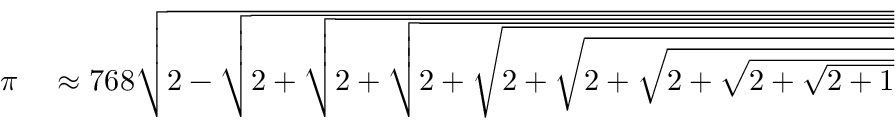<formula> <loc_0><loc_0><loc_500><loc_500>\begin{array} { r l } { \pi } & \approx 7 6 8 { \sqrt { 2 - { \sqrt { 2 + { \sqrt { 2 + { \sqrt { 2 + { \sqrt { 2 + { \sqrt { 2 + { \sqrt { 2 + { \sqrt { 2 + { \sqrt { 2 + 1 } } } } } } } } } } } } } } } } } } } \end{array}</formula> 